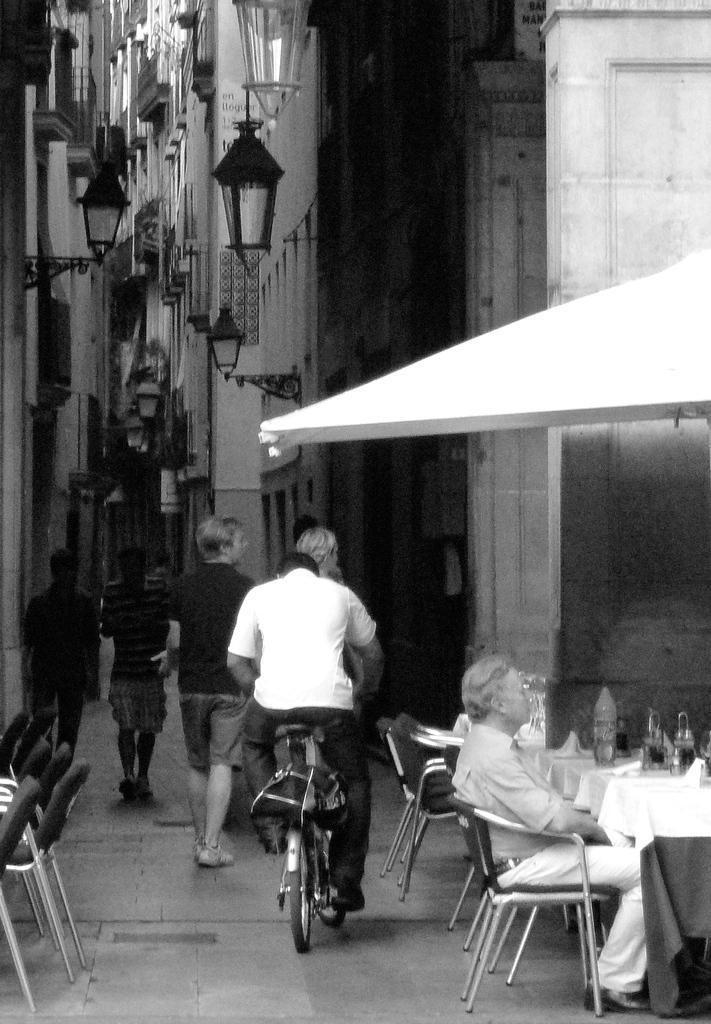Can you describe this image briefly? In this image, there is an outside view of a building. There are three persons in the bottom left of the image walking on the street. There is a person who is in the center of the image riding a bicycle. There is a person in bottom right of the image sitting on chair in front of the table. This table is covered with a cloth. There are some lights at the top left of the image. There are some chairs in the bottom left of the image. 